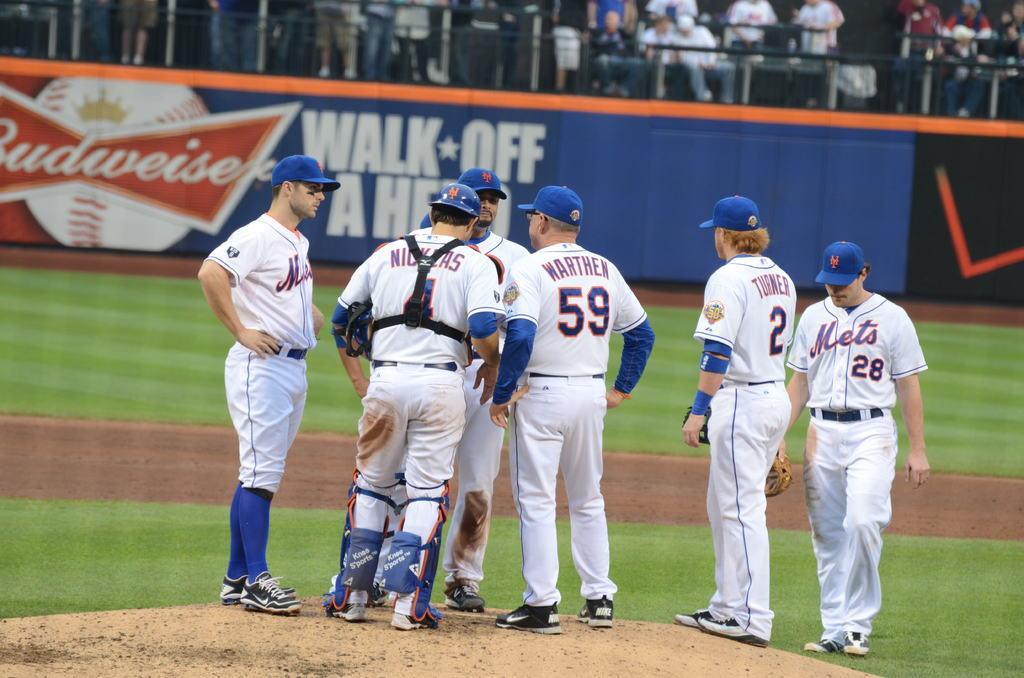Could you give a brief overview of what you see in this image? There are group of people standing. They wore caps, T-shirts, trouser and shoes. I think this is a baseball ground. This is a hoarding. In the background, I can see few people sitting and standing. 